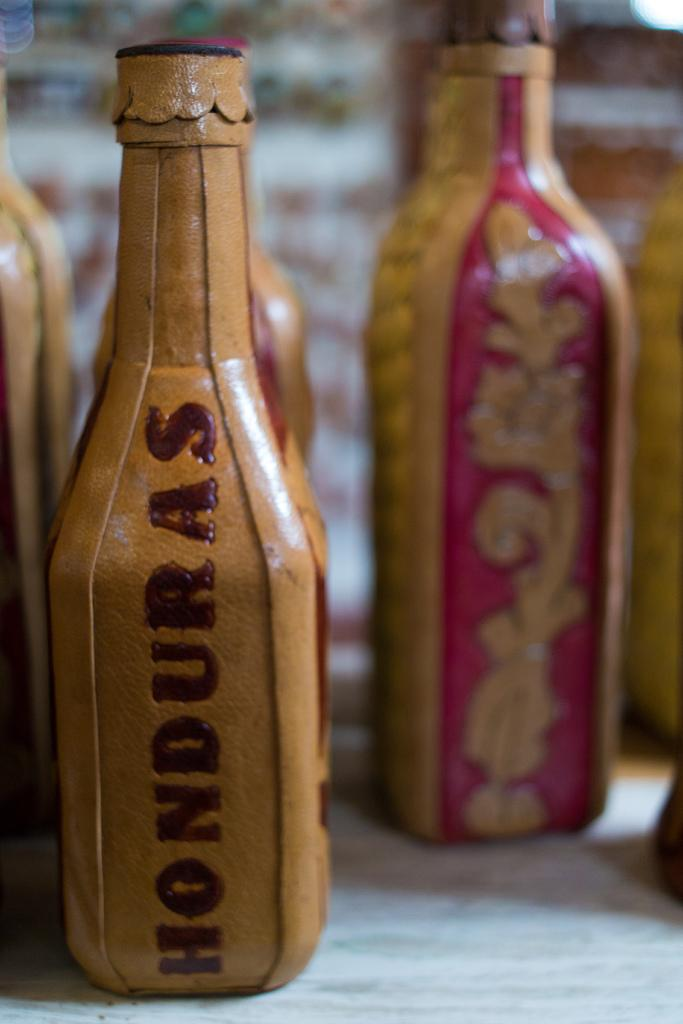<image>
Provide a brief description of the given image. A pretty pink and tan bottle has Honduras written on the side, 